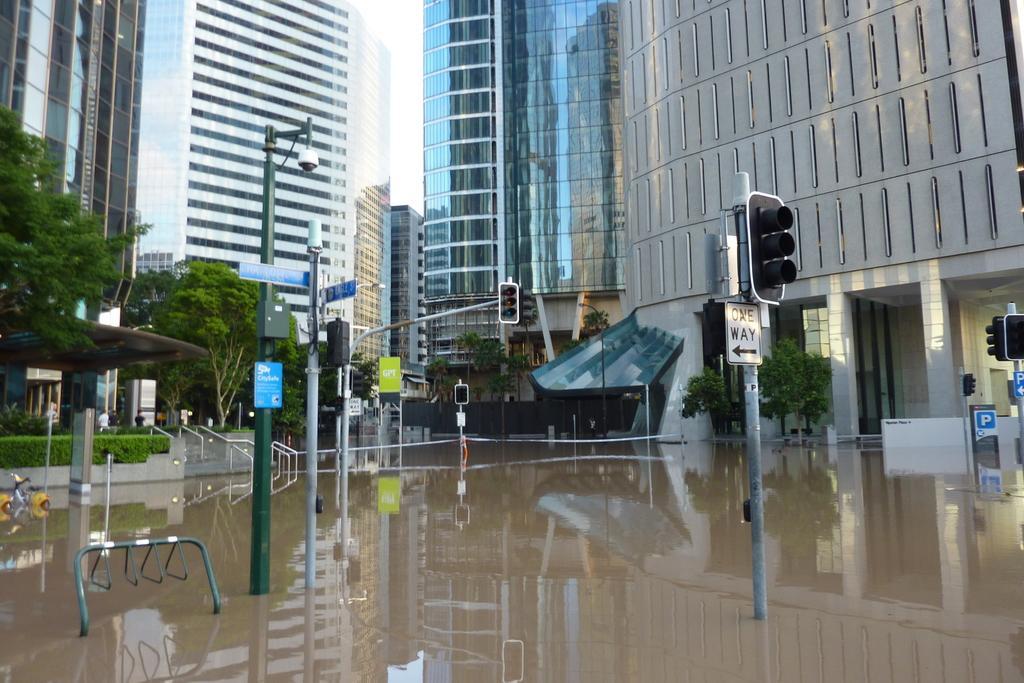In one or two sentences, can you explain what this image depicts? In the image we can see there are buildings and trees. Here we can see signal poles and light poles. Here we can see plants, water and the white sky. Here we can see a person wearing clothes. 